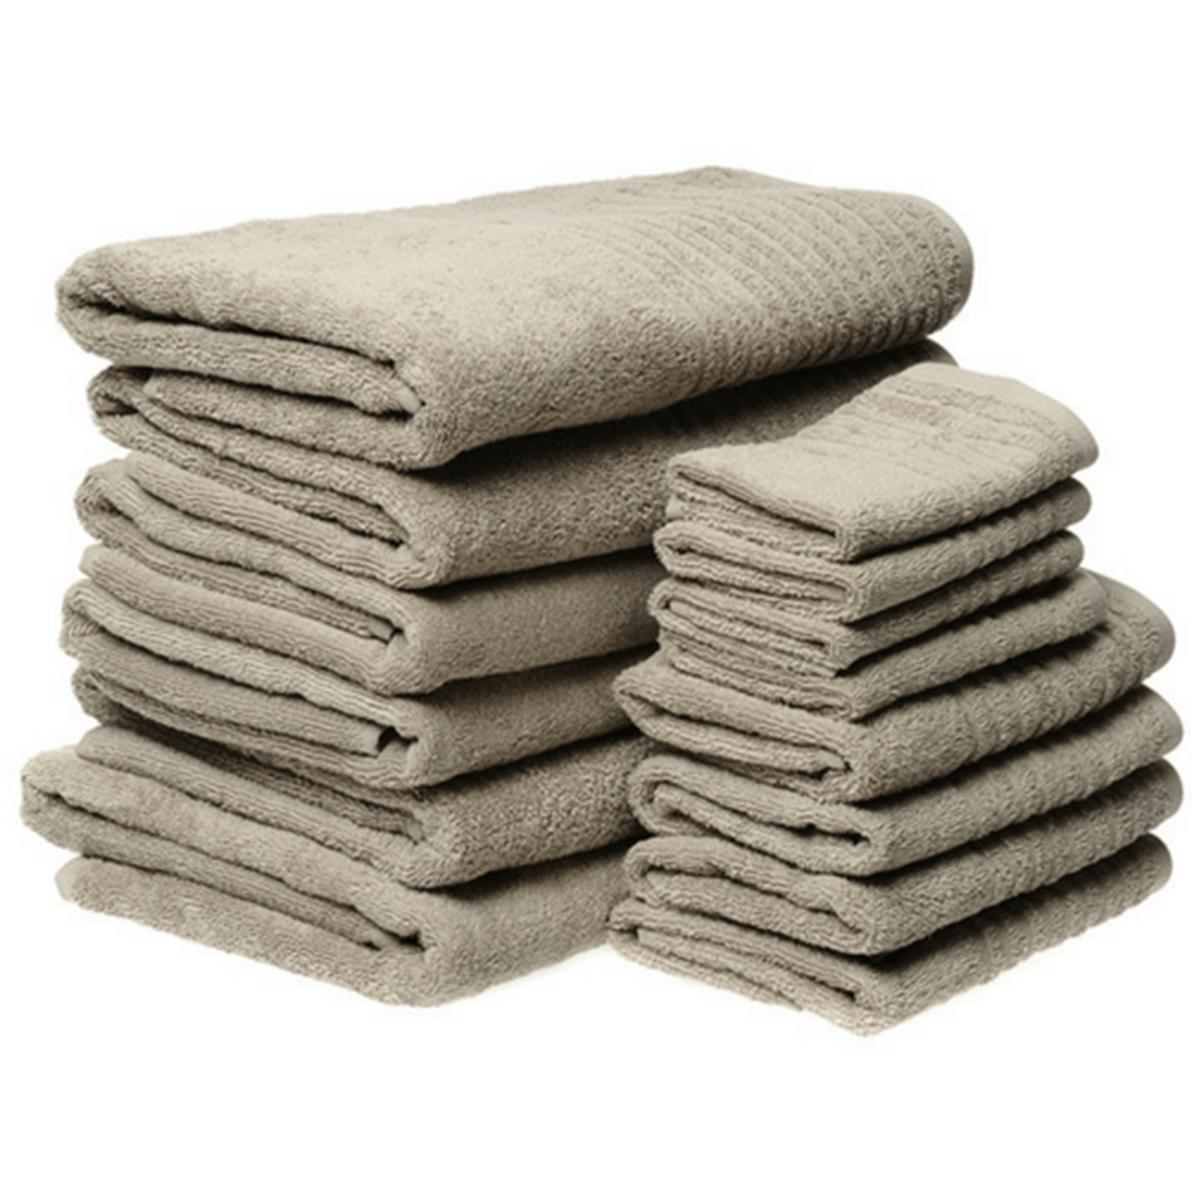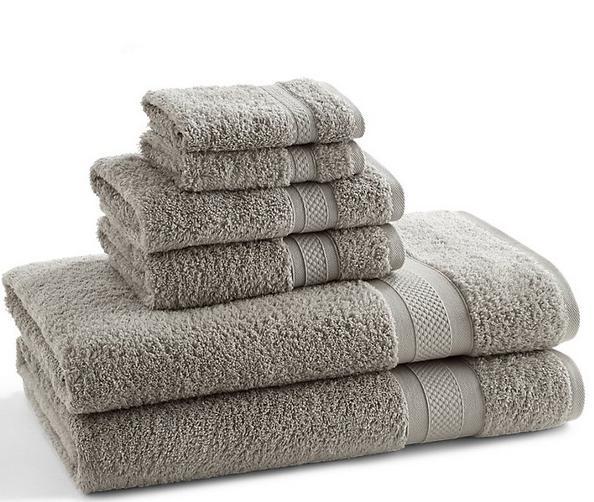The first image is the image on the left, the second image is the image on the right. Considering the images on both sides, is "There are 4 bath-towels of equal size stacked on top of each other" valid? Answer yes or no. No. The first image is the image on the left, the second image is the image on the right. Considering the images on both sides, is "Each image contains different towel sizes, and at least one image shows at least three different towel sizes in one stack." valid? Answer yes or no. Yes. 